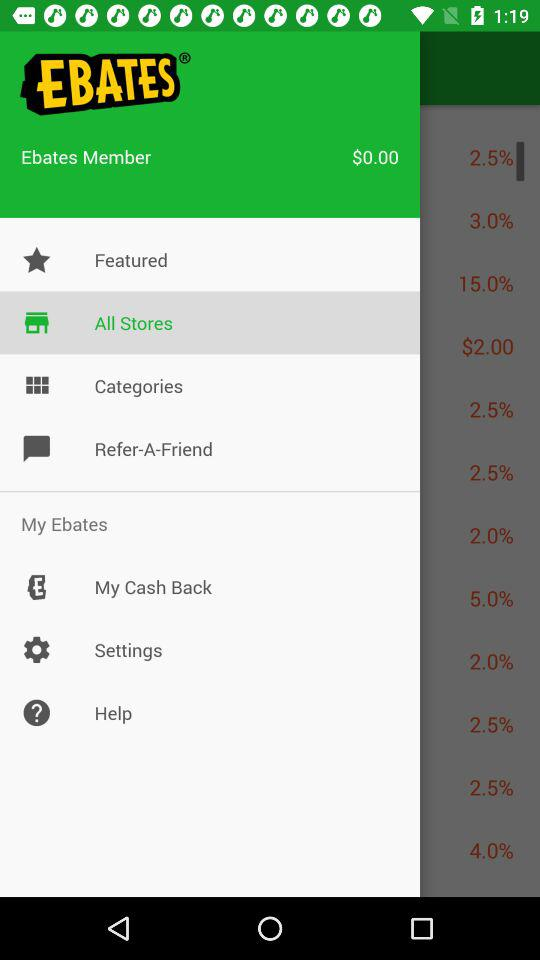Which option is selected? The selected option is "All Stores". 